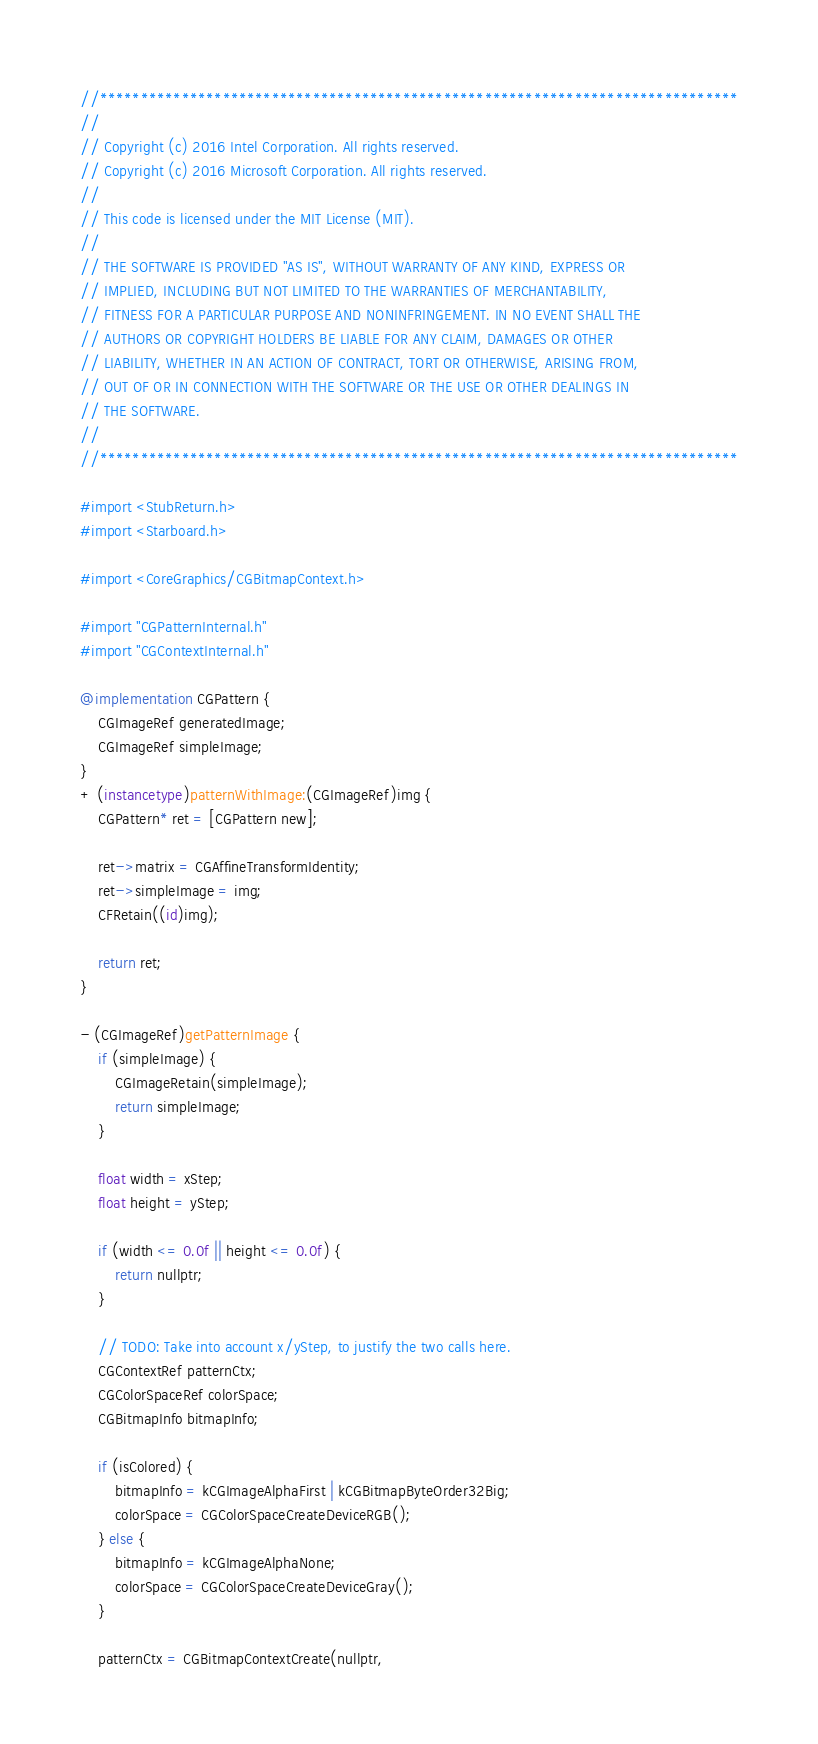Convert code to text. <code><loc_0><loc_0><loc_500><loc_500><_ObjectiveC_>//******************************************************************************
//
// Copyright (c) 2016 Intel Corporation. All rights reserved.
// Copyright (c) 2016 Microsoft Corporation. All rights reserved.
//
// This code is licensed under the MIT License (MIT).
//
// THE SOFTWARE IS PROVIDED "AS IS", WITHOUT WARRANTY OF ANY KIND, EXPRESS OR
// IMPLIED, INCLUDING BUT NOT LIMITED TO THE WARRANTIES OF MERCHANTABILITY,
// FITNESS FOR A PARTICULAR PURPOSE AND NONINFRINGEMENT. IN NO EVENT SHALL THE
// AUTHORS OR COPYRIGHT HOLDERS BE LIABLE FOR ANY CLAIM, DAMAGES OR OTHER
// LIABILITY, WHETHER IN AN ACTION OF CONTRACT, TORT OR OTHERWISE, ARISING FROM,
// OUT OF OR IN CONNECTION WITH THE SOFTWARE OR THE USE OR OTHER DEALINGS IN
// THE SOFTWARE.
//
//******************************************************************************

#import <StubReturn.h>
#import <Starboard.h>

#import <CoreGraphics/CGBitmapContext.h>

#import "CGPatternInternal.h"
#import "CGContextInternal.h"

@implementation CGPattern {
    CGImageRef generatedImage;
    CGImageRef simpleImage;
}
+ (instancetype)patternWithImage:(CGImageRef)img {
    CGPattern* ret = [CGPattern new];

    ret->matrix = CGAffineTransformIdentity;
    ret->simpleImage = img;
    CFRetain((id)img);

    return ret;
}

- (CGImageRef)getPatternImage {
    if (simpleImage) {
        CGImageRetain(simpleImage);
        return simpleImage;
    }

    float width = xStep;
    float height = yStep;

    if (width <= 0.0f || height <= 0.0f) {
        return nullptr;
    }

    // TODO: Take into account x/yStep, to justify the two calls here.
    CGContextRef patternCtx;
    CGColorSpaceRef colorSpace;
    CGBitmapInfo bitmapInfo;

    if (isColored) {
        bitmapInfo = kCGImageAlphaFirst | kCGBitmapByteOrder32Big;
        colorSpace = CGColorSpaceCreateDeviceRGB();
    } else {
        bitmapInfo = kCGImageAlphaNone;
        colorSpace = CGColorSpaceCreateDeviceGray();
    }

    patternCtx = CGBitmapContextCreate(nullptr,</code> 